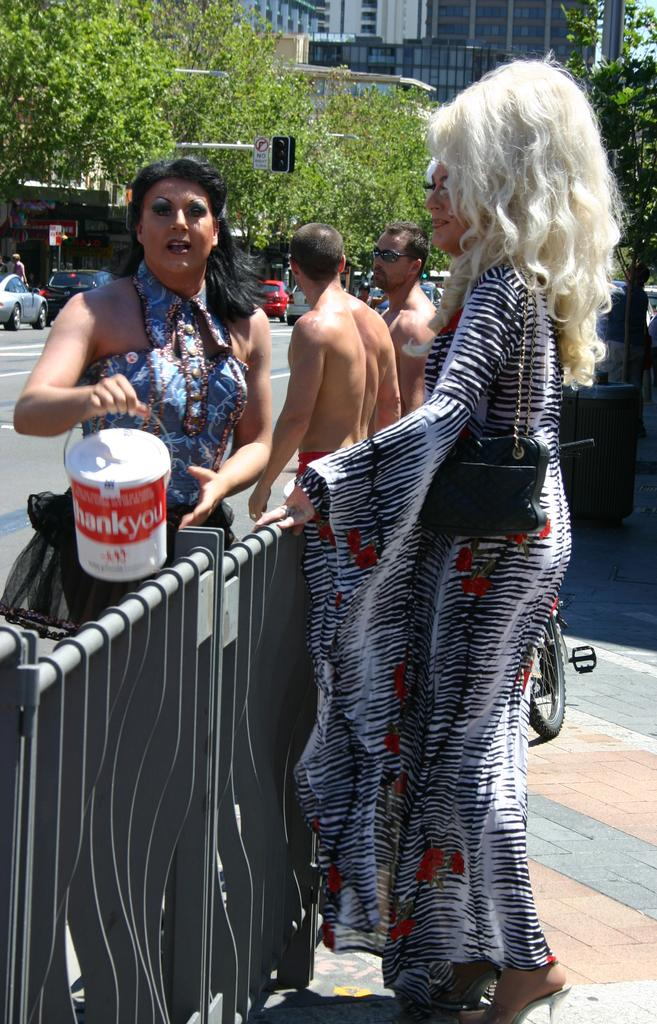Who or what is present in the image? There are people in the image. What is located at the bottom of the image? There is a fence at the bottom of the image. What can be seen in the background of the image? There are cars, trees, buildings, and a traffic light in the background of the image. How many dimes are scattered on the ground in the image? There are no dimes present in the image. What type of lumber is being used to construct the buildings in the image? The image does not provide information about the type of lumber used in the construction of the buildings. 